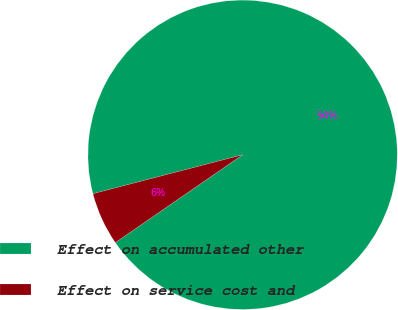Convert chart. <chart><loc_0><loc_0><loc_500><loc_500><pie_chart><fcel>Effect on accumulated other<fcel>Effect on service cost and<nl><fcel>94.44%<fcel>5.56%<nl></chart> 